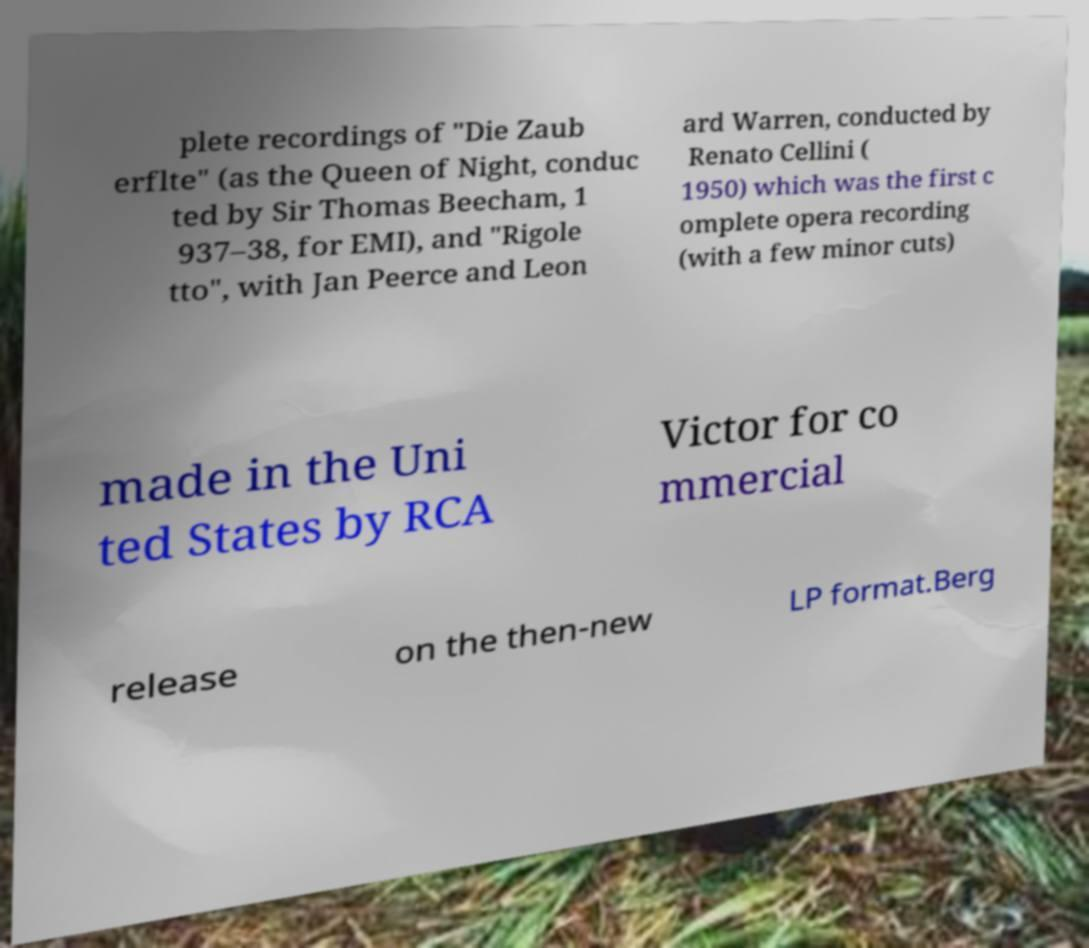Could you extract and type out the text from this image? plete recordings of "Die Zaub erflte" (as the Queen of Night, conduc ted by Sir Thomas Beecham, 1 937–38, for EMI), and "Rigole tto", with Jan Peerce and Leon ard Warren, conducted by Renato Cellini ( 1950) which was the first c omplete opera recording (with a few minor cuts) made in the Uni ted States by RCA Victor for co mmercial release on the then-new LP format.Berg 